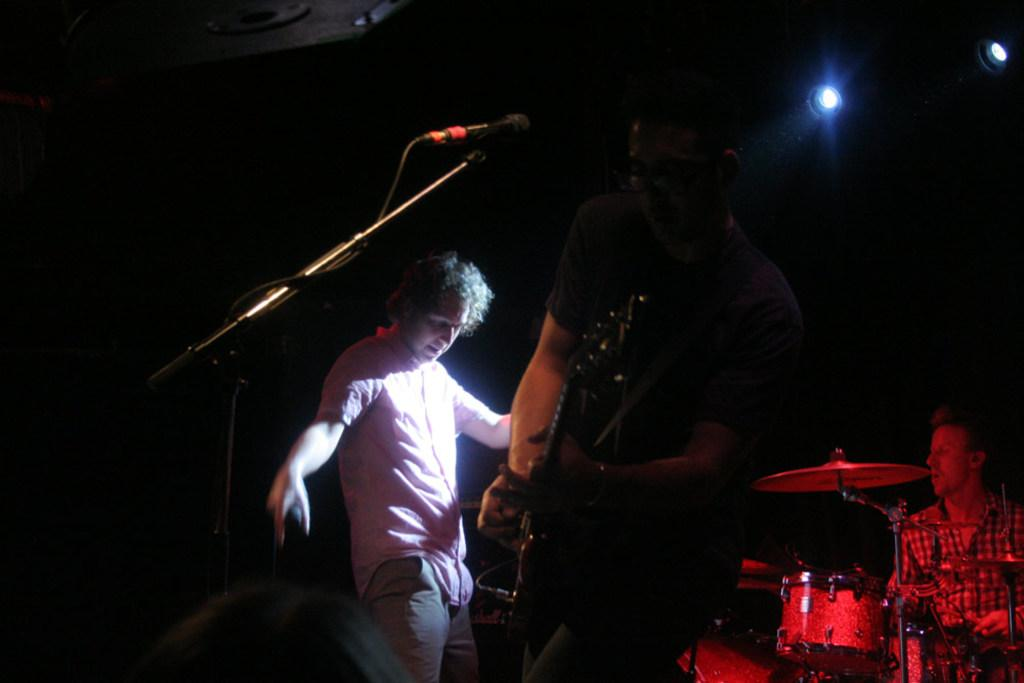What are the people in the image doing? There are people standing in the image, and a man is holding a guitar. What musical instrument is present in the image besides the guitar? There is a drum set in the image. What is the position of the man in relation to the drum set? A man is sitting in front of the drum set. What type of toy is the man playing with in the image? There is no toy present in the image; the man is holding a guitar and sitting in front of a drum set. 